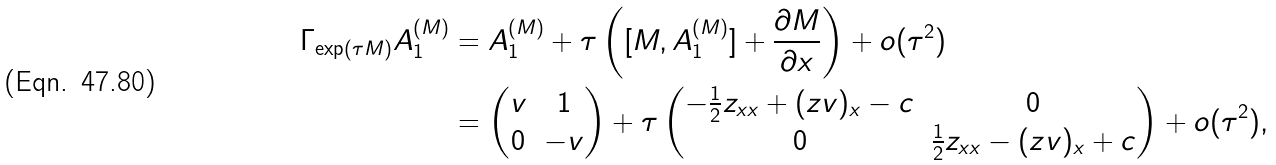<formula> <loc_0><loc_0><loc_500><loc_500>\Gamma _ { \exp ( \tau M ) } A _ { 1 } ^ { ( M ) } & = A _ { 1 } ^ { ( M ) } + \tau \left ( [ M , A _ { 1 } ^ { ( M ) } ] + \frac { \partial M } { \partial x } \right ) + o ( \tau ^ { 2 } ) \\ & = \begin{pmatrix} v & 1 \\ 0 & - v \end{pmatrix} + \tau \begin{pmatrix} - \frac { 1 } { 2 } z _ { x x } + ( z v ) _ { x } - c & 0 \\ 0 & \frac { 1 } { 2 } z _ { x x } - ( z v ) _ { x } + c \end{pmatrix} + o ( \tau ^ { 2 } ) ,</formula> 